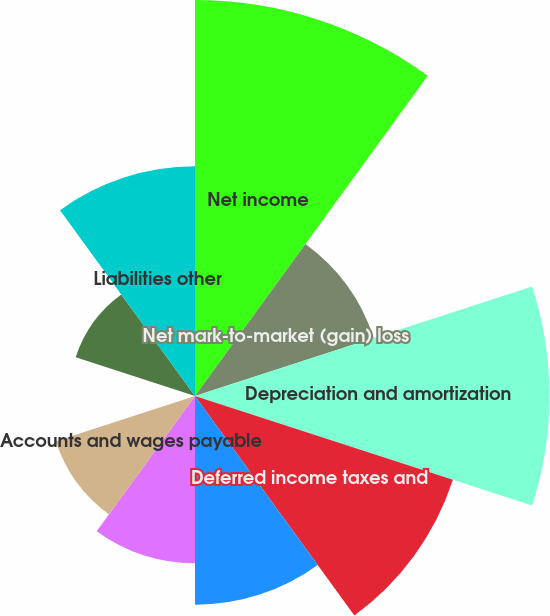Convert chart to OTSL. <chart><loc_0><loc_0><loc_500><loc_500><pie_chart><fcel>Net income<fcel>Net mark-to-market (gain) loss<fcel>Depreciation and amortization<fcel>Deferred income taxes and<fcel>Receivables<fcel>Materials and supplies<fcel>Accounts and wages payable<fcel>Taxes accrued<fcel>Assets other<fcel>Liabilities other<nl><fcel>18.97%<fcel>9.0%<fcel>16.98%<fcel>12.99%<fcel>10.0%<fcel>8.01%<fcel>7.01%<fcel>0.03%<fcel>6.01%<fcel>11.0%<nl></chart> 